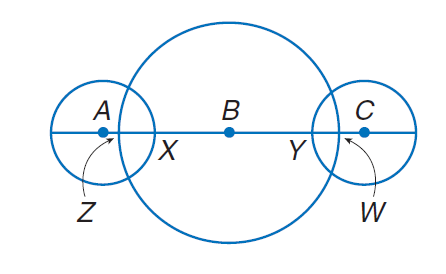Answer the mathemtical geometry problem and directly provide the correct option letter.
Question: The diameters of \odot A, \odot B, and \odot C are 10, 30 and 10 units, respectively. Find A Z if A Z \cong C W and C W = 2.
Choices: A: 2 B: 4 C: 10 D: 30 A 